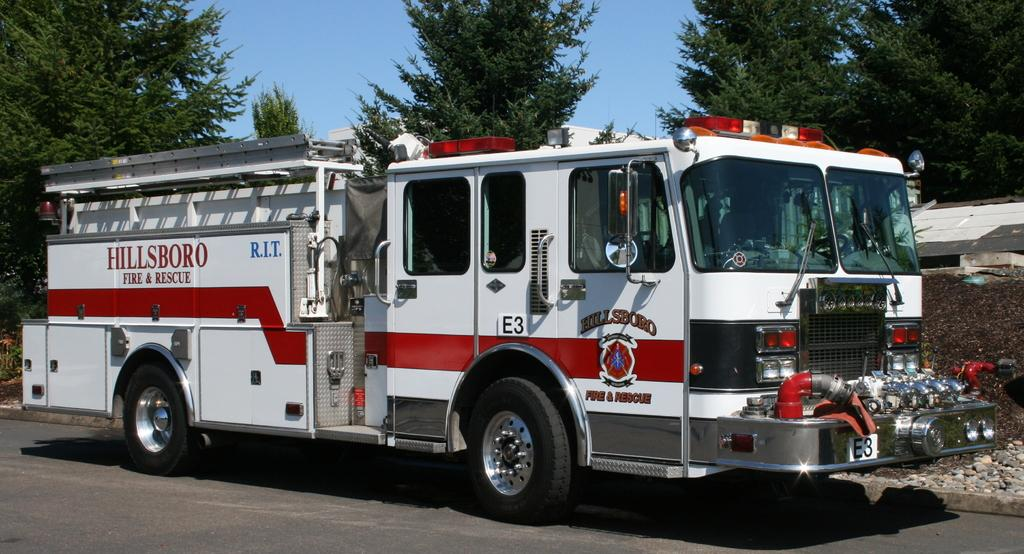What is on the road in the image? There is a vehicle on the road in the image. What can be seen on the right side of the image? There is a wall on the right side of the image. What type of vegetation is visible in the background of the image? There are trees in the background of the image. What is visible at the top of the image? The sky is visible at the top of the image. What type of head can be seen on the vehicle in the image? There is no head visible on the vehicle in the image. What action is the vehicle performing in the image? The image does not show the vehicle performing any specific action; it is simply parked or driving on the road. 